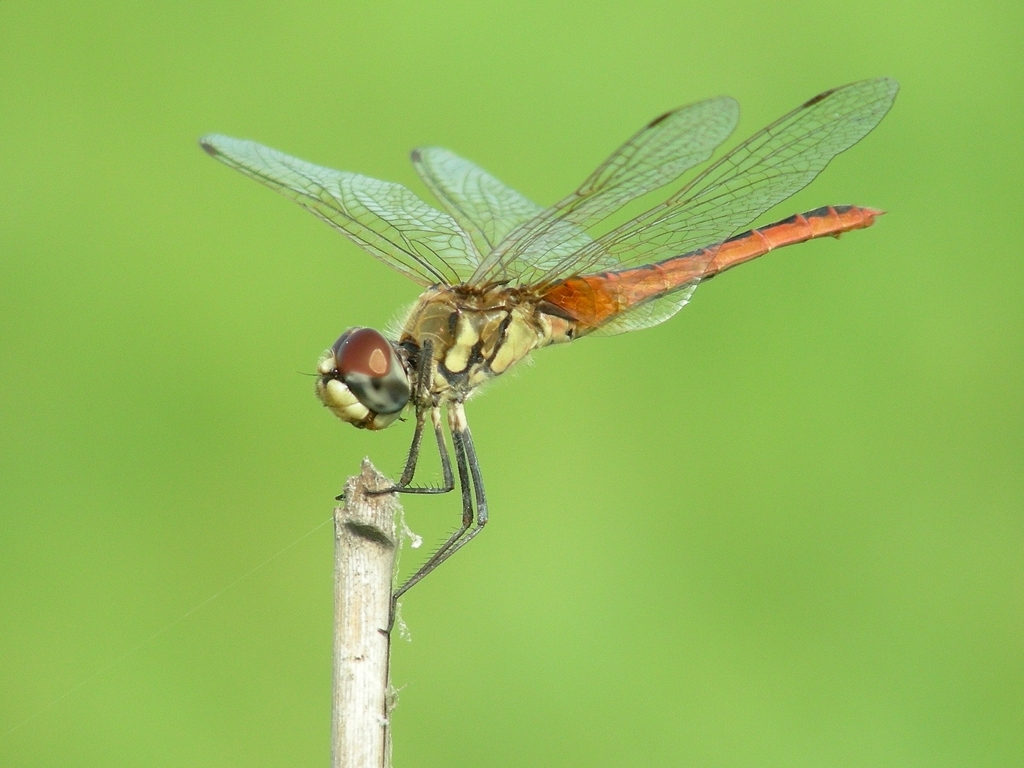What is the significance of a dragonfly's wing structure? A dragonfly's wing structure is remarkable for its intricate vein pattern which provides strength and flexibility, enabling complex flight maneuvers. These wings are a subject of study for biomimicry in engineering and design, especially in the creation of efficient flying robots and drones. 